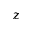Convert formula to latex. <formula><loc_0><loc_0><loc_500><loc_500>z</formula> 